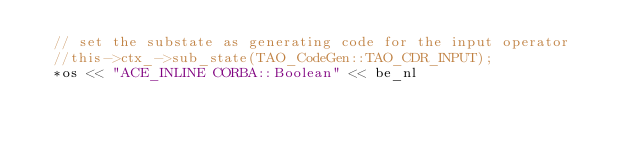Convert code to text. <code><loc_0><loc_0><loc_500><loc_500><_C++_>  // set the substate as generating code for the input operator
  //this->ctx_->sub_state(TAO_CodeGen::TAO_CDR_INPUT);
  *os << "ACE_INLINE CORBA::Boolean" << be_nl</code> 